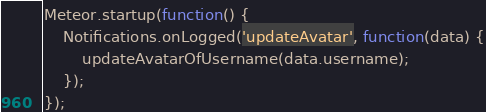Convert code to text. <code><loc_0><loc_0><loc_500><loc_500><_JavaScript_>Meteor.startup(function() {
	Notifications.onLogged('updateAvatar', function(data) {
		updateAvatarOfUsername(data.username);
	});
});
</code> 